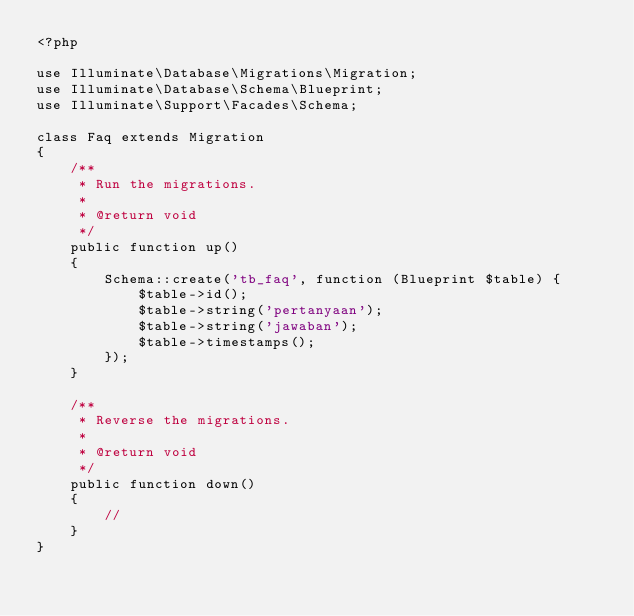<code> <loc_0><loc_0><loc_500><loc_500><_PHP_><?php

use Illuminate\Database\Migrations\Migration;
use Illuminate\Database\Schema\Blueprint;
use Illuminate\Support\Facades\Schema;

class Faq extends Migration
{
    /**
     * Run the migrations.
     *
     * @return void
     */
    public function up()
    {
        Schema::create('tb_faq', function (Blueprint $table) {
            $table->id();
            $table->string('pertanyaan');
            $table->string('jawaban');
            $table->timestamps();
        });
    }

    /**
     * Reverse the migrations.
     *
     * @return void
     */
    public function down()
    {
        //
    }
}
</code> 